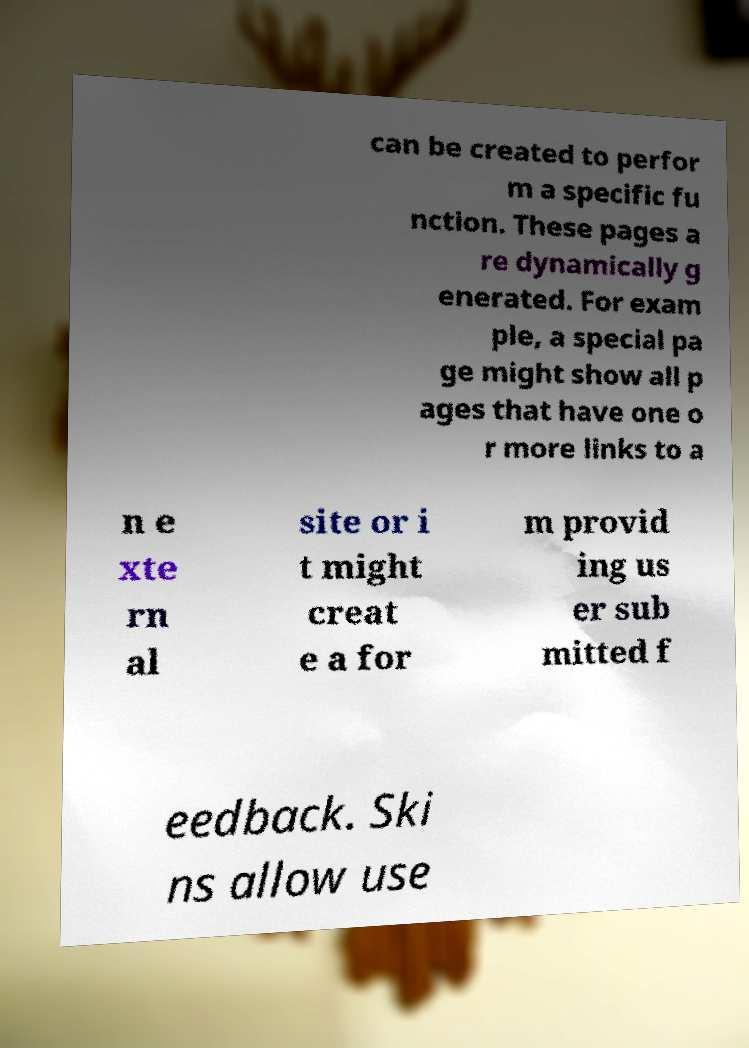Please read and relay the text visible in this image. What does it say? can be created to perfor m a specific fu nction. These pages a re dynamically g enerated. For exam ple, a special pa ge might show all p ages that have one o r more links to a n e xte rn al site or i t might creat e a for m provid ing us er sub mitted f eedback. Ski ns allow use 